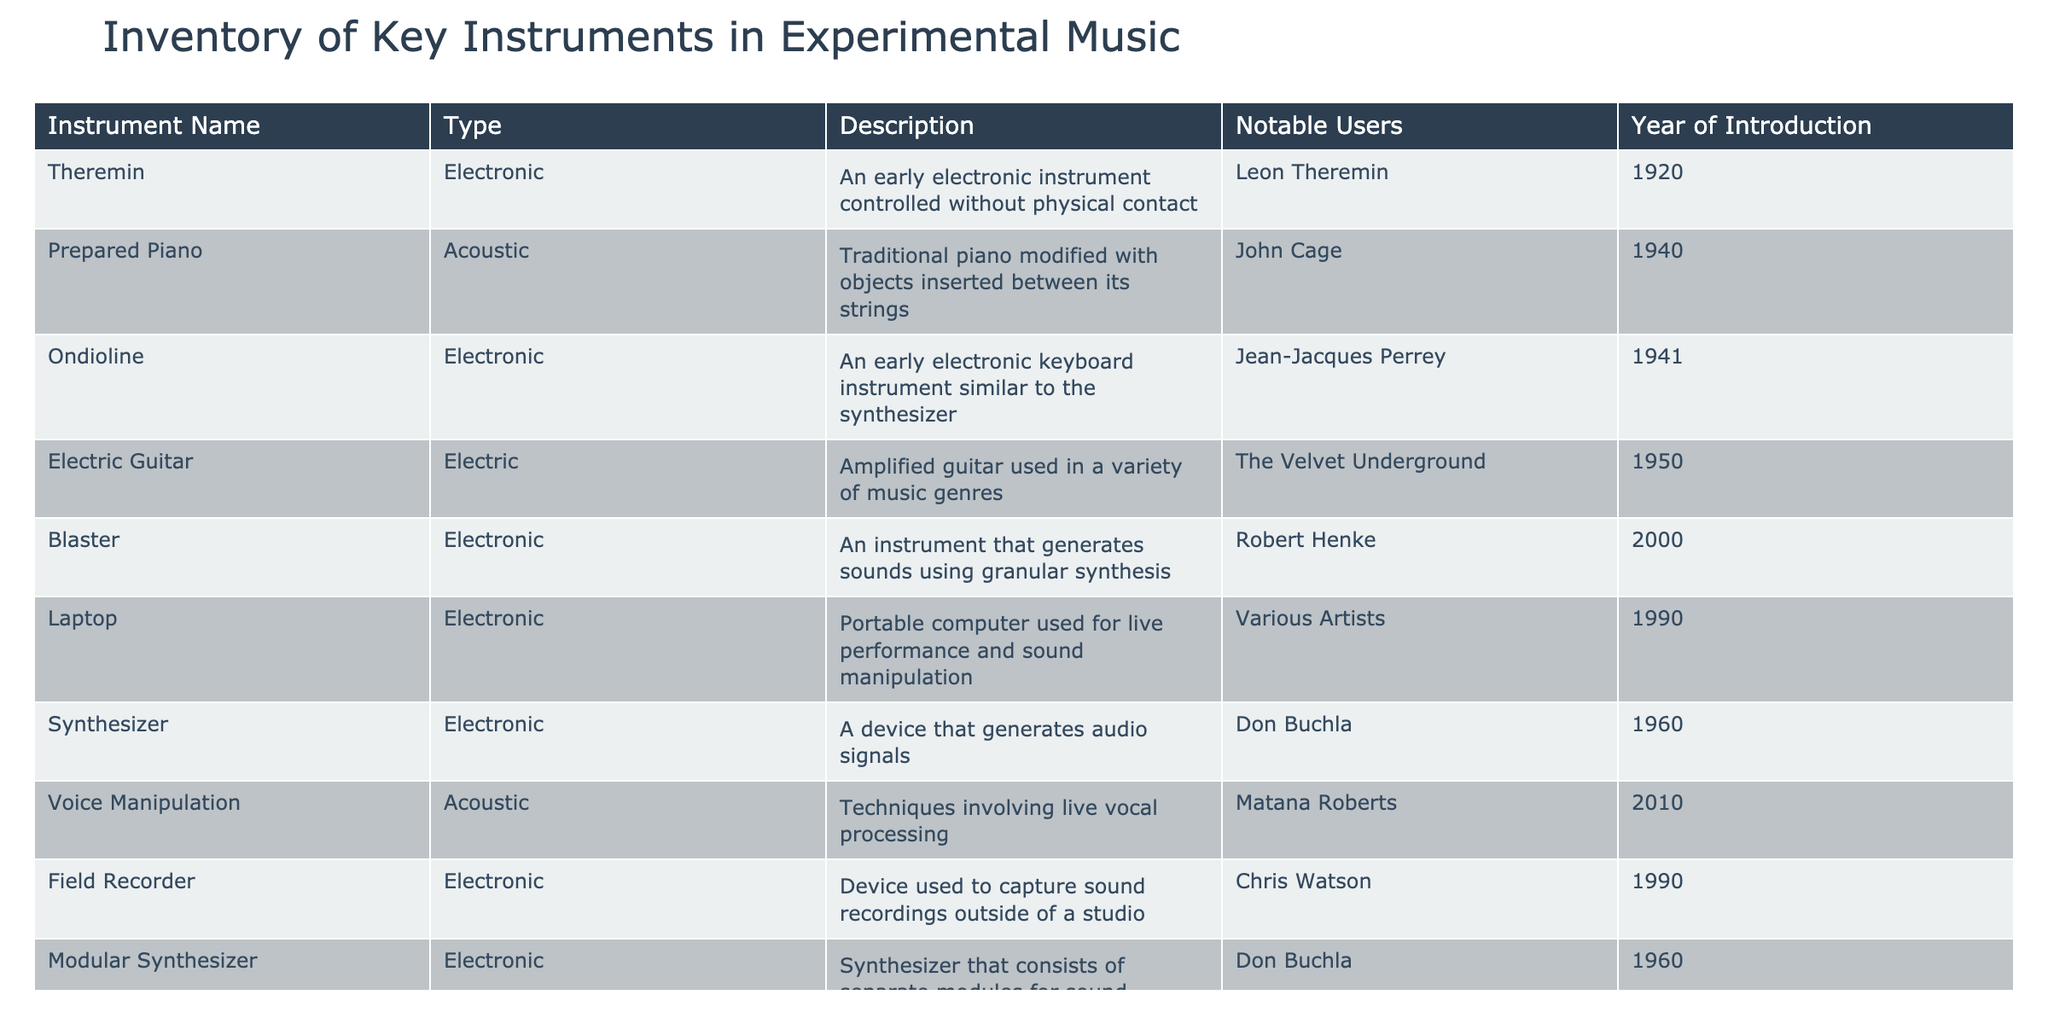What is the year of introduction of the Theremin? The table lists the Theremin in the first row under the "Year of Introduction" column. According to this row, the Theremin was introduced in 1920.
Answer: 1920 Who is a notable user of the Prepared Piano? Looking at the "Notable Users" column, John Cage is listed as a notable user of the Prepared Piano, which appears in the second row of the table.
Answer: John Cage How many electronic instruments are listed in the inventory? By counting the rows in the "Type" column that have 'Electronic', we find there are a total of 5 electronic instruments: Theremin, Ondioline, Blaster, Laptop, and Synthesizer.
Answer: 5 Is the Electric Guitar classified as an acoustic instrument? The table indicates that the type of the Electric Guitar is 'Electric'. Thus, it is not classified as an acoustic instrument.
Answer: No What is the difference between the year of introduction for the Modular Synthesizer and the Ondioline? The year of introduction for the Modular Synthesizer is 1960 and for the Ondioline, it is 1941. Therefore, 1960 - 1941 = 19 years difference.
Answer: 19 years Which instrument was introduced most recently, and in what year? Reviewing the "Year of Introduction" column, the most recent instrument is the Voice Manipulation, introduced in 2010. We can see all the years listed to confirm this is the highest.
Answer: 2010 Which notable user is associated with the Laptop? The "Notable Users" for Laptop is indicated as 'Various Artists' in the corresponding row. Thus, this is the answer.
Answer: Various Artists What types of instruments did Don Buchla contribute to? By inspecting the "Type" and "Instrument Name" columns, we can see that Don Buchla is associated with Synthesizer and Modular Synthesizer, both classified as electronic instruments.
Answer: Synthesizer and Modular Synthesizer How many instruments were introduced before the year 1950? By examining the years listed, the instruments introduced before 1950 are Theremin (1920), Prepared Piano (1940), Ondioline (1941), and Electric Guitar (1950). Thus, there are three instruments that were introduced before 1950.
Answer: 3 